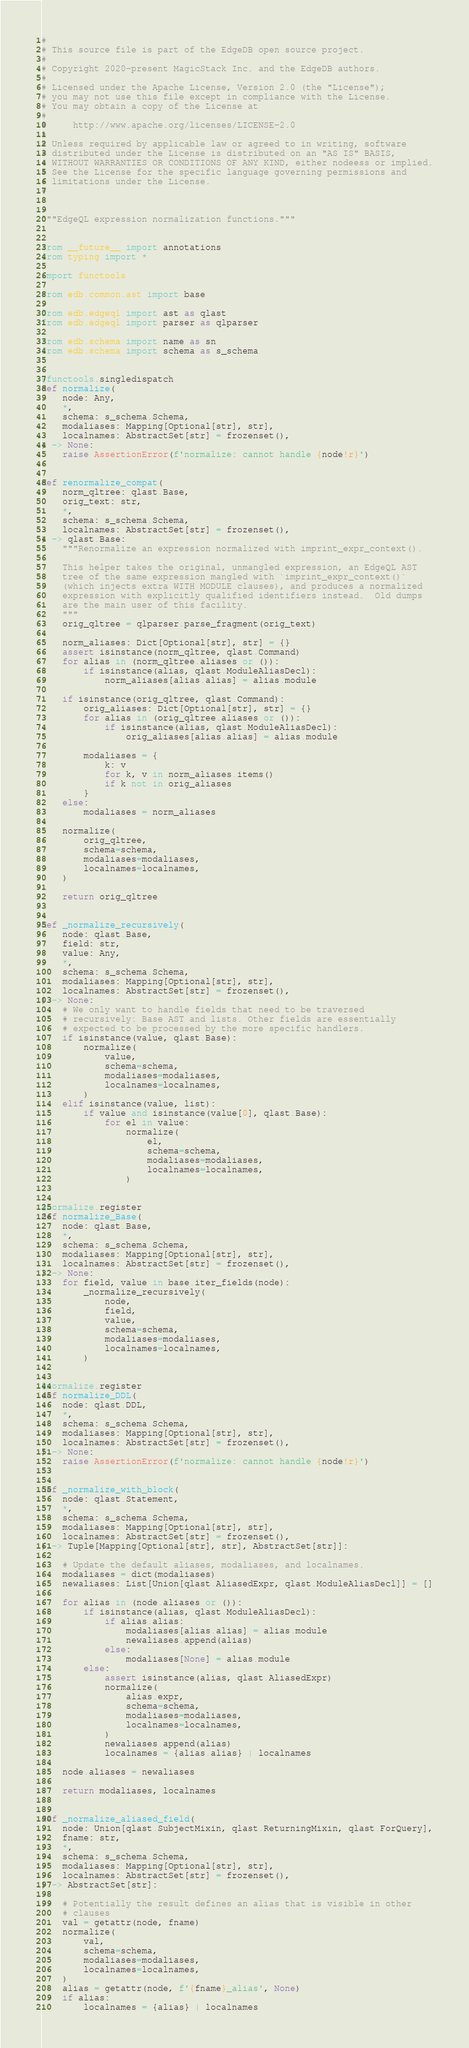Convert code to text. <code><loc_0><loc_0><loc_500><loc_500><_Python_>#
# This source file is part of the EdgeDB open source project.
#
# Copyright 2020-present MagicStack Inc. and the EdgeDB authors.
#
# Licensed under the Apache License, Version 2.0 (the "License");
# you may not use this file except in compliance with the License.
# You may obtain a copy of the License at
#
#     http://www.apache.org/licenses/LICENSE-2.0
#
# Unless required by applicable law or agreed to in writing, software
# distributed under the License is distributed on an "AS IS" BASIS,
# WITHOUT WARRANTIES OR CONDITIONS OF ANY KIND, either nodeess or implied.
# See the License for the specific language governing permissions and
# limitations under the License.
#


"""EdgeQL expression normalization functions."""


from __future__ import annotations
from typing import *

import functools

from edb.common.ast import base

from edb.edgeql import ast as qlast
from edb.edgeql import parser as qlparser

from edb.schema import name as sn
from edb.schema import schema as s_schema


@functools.singledispatch
def normalize(
    node: Any,
    *,
    schema: s_schema.Schema,
    modaliases: Mapping[Optional[str], str],
    localnames: AbstractSet[str] = frozenset(),
) -> None:
    raise AssertionError(f'normalize: cannot handle {node!r}')


def renormalize_compat(
    norm_qltree: qlast.Base,
    orig_text: str,
    *,
    schema: s_schema.Schema,
    localnames: AbstractSet[str] = frozenset(),
) -> qlast.Base:
    """Renormalize an expression normalized with imprint_expr_context().

    This helper takes the original, unmangled expression, an EdgeQL AST
    tree of the same expression mangled with `imprint_expr_context()`
    (which injects extra WITH MODULE clauses), and produces a normalized
    expression with explicitly qualified identifiers instead.  Old dumps
    are the main user of this facility.
    """
    orig_qltree = qlparser.parse_fragment(orig_text)

    norm_aliases: Dict[Optional[str], str] = {}
    assert isinstance(norm_qltree, qlast.Command)
    for alias in (norm_qltree.aliases or ()):
        if isinstance(alias, qlast.ModuleAliasDecl):
            norm_aliases[alias.alias] = alias.module

    if isinstance(orig_qltree, qlast.Command):
        orig_aliases: Dict[Optional[str], str] = {}
        for alias in (orig_qltree.aliases or ()):
            if isinstance(alias, qlast.ModuleAliasDecl):
                orig_aliases[alias.alias] = alias.module

        modaliases = {
            k: v
            for k, v in norm_aliases.items()
            if k not in orig_aliases
        }
    else:
        modaliases = norm_aliases

    normalize(
        orig_qltree,
        schema=schema,
        modaliases=modaliases,
        localnames=localnames,
    )

    return orig_qltree


def _normalize_recursively(
    node: qlast.Base,
    field: str,
    value: Any,
    *,
    schema: s_schema.Schema,
    modaliases: Mapping[Optional[str], str],
    localnames: AbstractSet[str] = frozenset(),
) -> None:
    # We only want to handle fields that need to be traversed
    # recursively: Base AST and lists. Other fields are essentially
    # expected to be processed by the more specific handlers.
    if isinstance(value, qlast.Base):
        normalize(
            value,
            schema=schema,
            modaliases=modaliases,
            localnames=localnames,
        )
    elif isinstance(value, list):
        if value and isinstance(value[0], qlast.Base):
            for el in value:
                normalize(
                    el,
                    schema=schema,
                    modaliases=modaliases,
                    localnames=localnames,
                )


@normalize.register
def normalize_Base(
    node: qlast.Base,
    *,
    schema: s_schema.Schema,
    modaliases: Mapping[Optional[str], str],
    localnames: AbstractSet[str] = frozenset(),
) -> None:
    for field, value in base.iter_fields(node):
        _normalize_recursively(
            node,
            field,
            value,
            schema=schema,
            modaliases=modaliases,
            localnames=localnames,
        )


@normalize.register
def normalize_DDL(
    node: qlast.DDL,
    *,
    schema: s_schema.Schema,
    modaliases: Mapping[Optional[str], str],
    localnames: AbstractSet[str] = frozenset(),
) -> None:
    raise AssertionError(f'normalize: cannot handle {node!r}')


def _normalize_with_block(
    node: qlast.Statement,
    *,
    schema: s_schema.Schema,
    modaliases: Mapping[Optional[str], str],
    localnames: AbstractSet[str] = frozenset(),
) -> Tuple[Mapping[Optional[str], str], AbstractSet[str]]:

    # Update the default aliases, modaliases, and localnames.
    modaliases = dict(modaliases)
    newaliases: List[Union[qlast.AliasedExpr, qlast.ModuleAliasDecl]] = []

    for alias in (node.aliases or ()):
        if isinstance(alias, qlast.ModuleAliasDecl):
            if alias.alias:
                modaliases[alias.alias] = alias.module
                newaliases.append(alias)
            else:
                modaliases[None] = alias.module
        else:
            assert isinstance(alias, qlast.AliasedExpr)
            normalize(
                alias.expr,
                schema=schema,
                modaliases=modaliases,
                localnames=localnames,
            )
            newaliases.append(alias)
            localnames = {alias.alias} | localnames

    node.aliases = newaliases

    return modaliases, localnames


def _normalize_aliased_field(
    node: Union[qlast.SubjectMixin, qlast.ReturningMixin, qlast.ForQuery],
    fname: str,
    *,
    schema: s_schema.Schema,
    modaliases: Mapping[Optional[str], str],
    localnames: AbstractSet[str] = frozenset(),
) -> AbstractSet[str]:

    # Potentially the result defines an alias that is visible in other
    # clauses
    val = getattr(node, fname)
    normalize(
        val,
        schema=schema,
        modaliases=modaliases,
        localnames=localnames,
    )
    alias = getattr(node, f'{fname}_alias', None)
    if alias:
        localnames = {alias} | localnames
</code> 